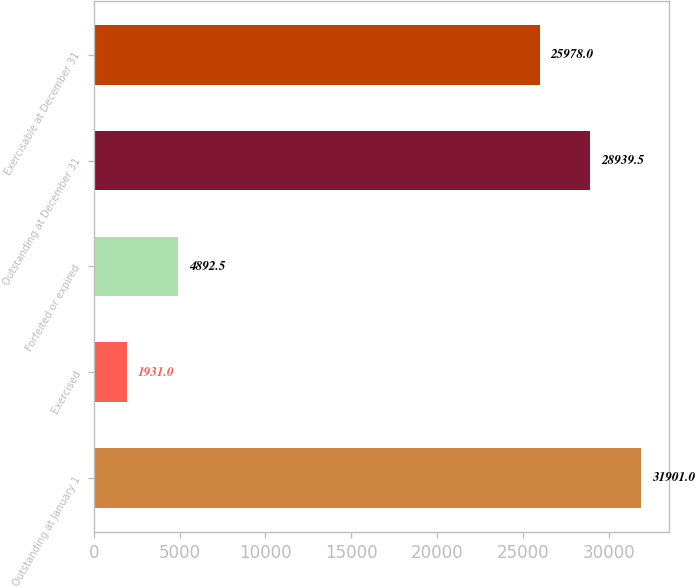Convert chart to OTSL. <chart><loc_0><loc_0><loc_500><loc_500><bar_chart><fcel>Outstanding at January 1<fcel>Exercised<fcel>Forfeited or expired<fcel>Outstanding at December 31<fcel>Exercisable at December 31<nl><fcel>31901<fcel>1931<fcel>4892.5<fcel>28939.5<fcel>25978<nl></chart> 